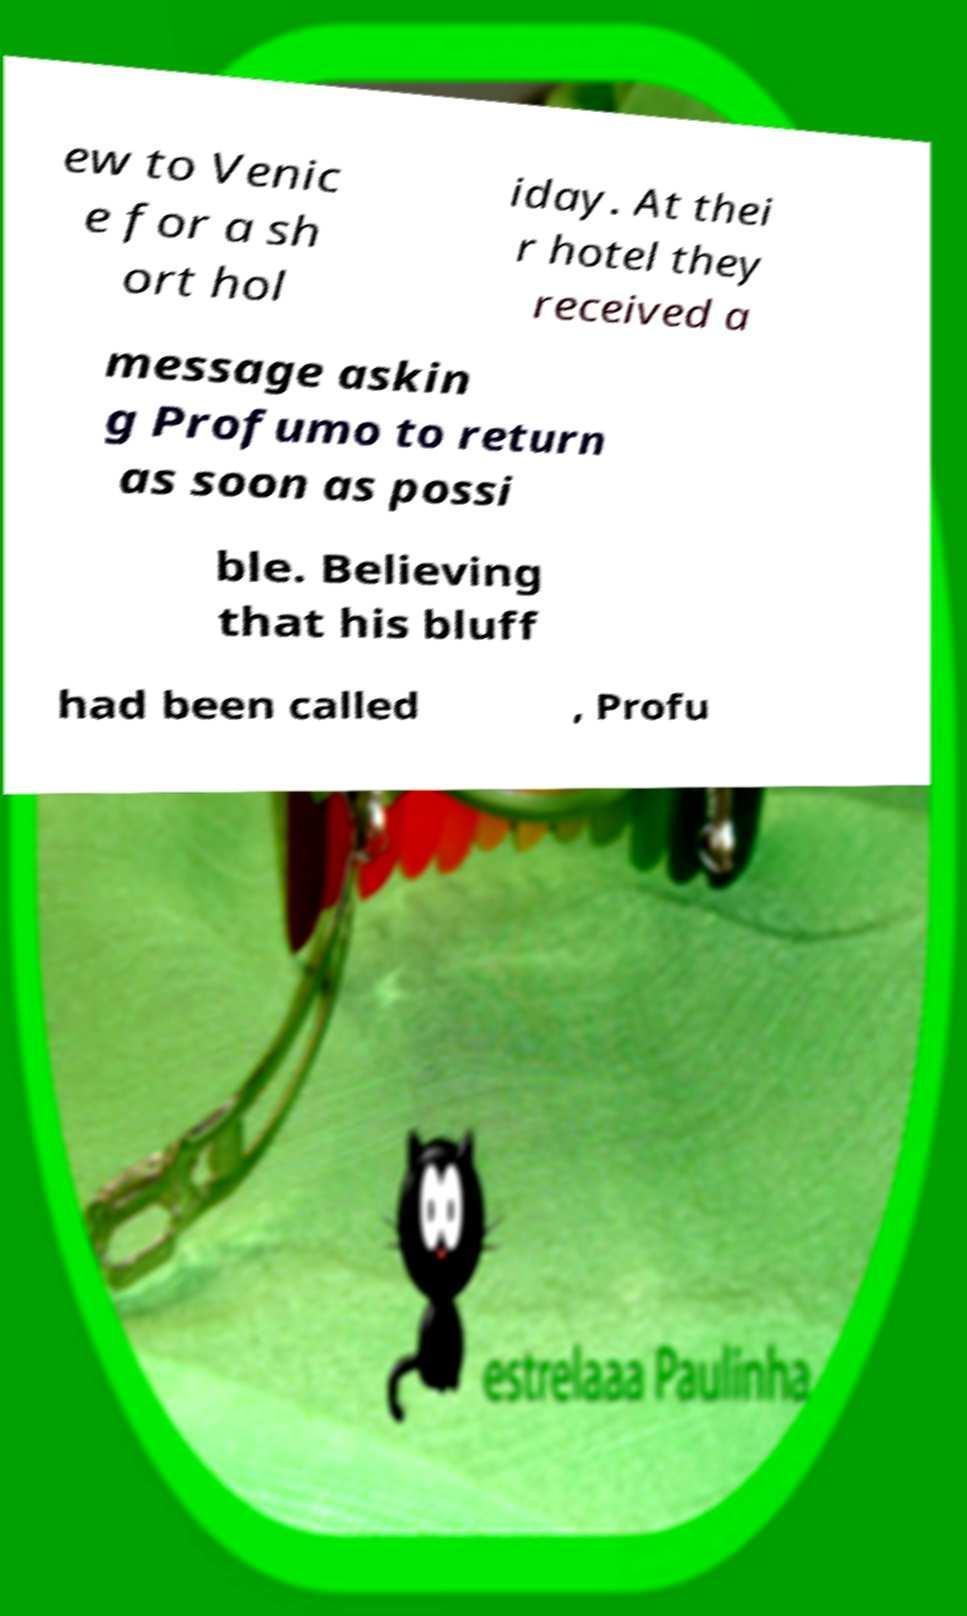Please identify and transcribe the text found in this image. ew to Venic e for a sh ort hol iday. At thei r hotel they received a message askin g Profumo to return as soon as possi ble. Believing that his bluff had been called , Profu 